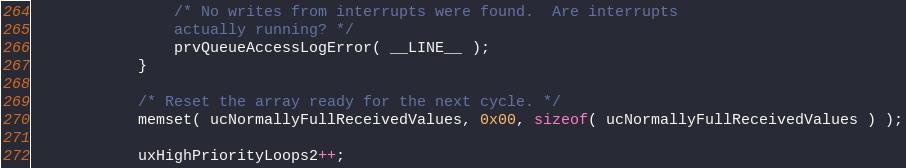Convert code to text. <code><loc_0><loc_0><loc_500><loc_500><_C_>				/* No writes from interrupts were found.  Are interrupts
				actually running? */
				prvQueueAccessLogError( __LINE__ );
			}

			/* Reset the array ready for the next cycle. */
			memset( ucNormallyFullReceivedValues, 0x00, sizeof( ucNormallyFullReceivedValues ) );

			uxHighPriorityLoops2++;</code> 